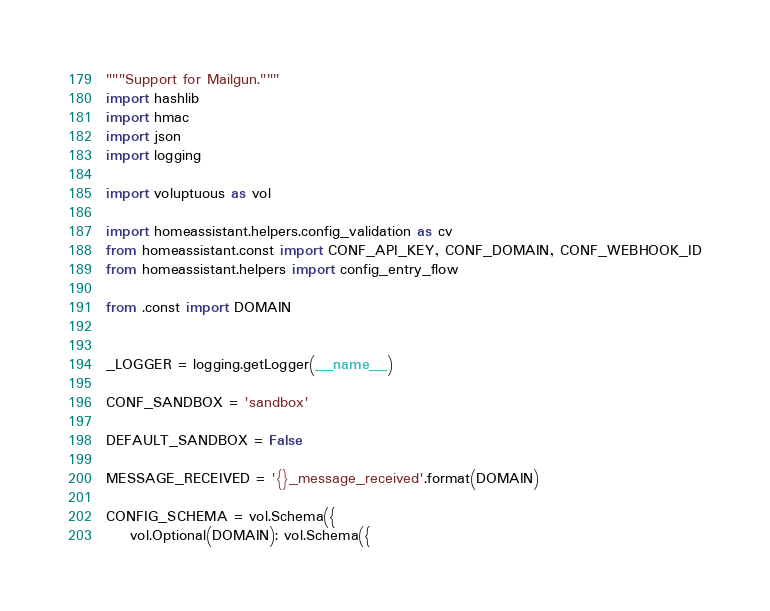<code> <loc_0><loc_0><loc_500><loc_500><_Python_>"""Support for Mailgun."""
import hashlib
import hmac
import json
import logging

import voluptuous as vol

import homeassistant.helpers.config_validation as cv
from homeassistant.const import CONF_API_KEY, CONF_DOMAIN, CONF_WEBHOOK_ID
from homeassistant.helpers import config_entry_flow

from .const import DOMAIN


_LOGGER = logging.getLogger(__name__)

CONF_SANDBOX = 'sandbox'

DEFAULT_SANDBOX = False

MESSAGE_RECEIVED = '{}_message_received'.format(DOMAIN)

CONFIG_SCHEMA = vol.Schema({
    vol.Optional(DOMAIN): vol.Schema({</code> 